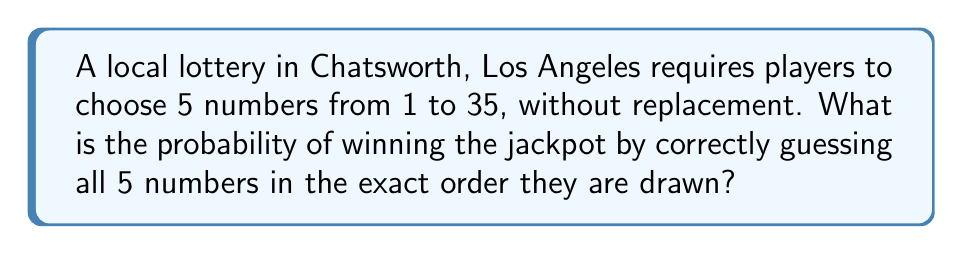Help me with this question. Let's approach this step-by-step:

1) First, we need to understand what the question is asking. We are choosing 5 numbers from 35, and the order matters.

2) This scenario is a permutation problem. We are selecting 5 numbers out of 35, where the order is important.

3) The total number of possible ways to arrange 5 numbers out of 35 is given by the permutation formula:

   $$P(35,5) = \frac{35!}{(35-5)!} = \frac{35!}{30!}$$

4) Let's calculate this:
   
   $$\frac{35!}{30!} = 35 \times 34 \times 33 \times 32 \times 31 = 38,955,840$$

5) Now, there is only one way to win the jackpot - by correctly guessing all 5 numbers in the exact order.

6) Therefore, the probability of winning is:

   $$P(\text{winning}) = \frac{\text{favorable outcomes}}{\text{total outcomes}} = \frac{1}{38,955,840}$$

Thus, the probability of winning this local Chatsworth lottery is 1 in 38,955,840.
Answer: $\frac{1}{38,955,840}$ 